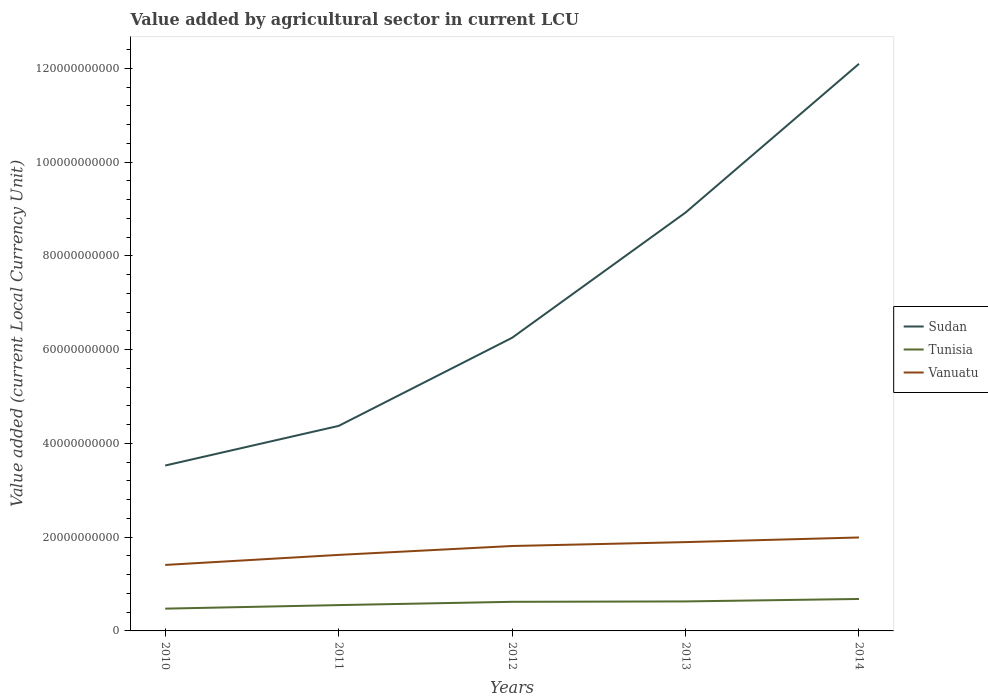How many different coloured lines are there?
Make the answer very short. 3. Is the number of lines equal to the number of legend labels?
Keep it short and to the point. Yes. Across all years, what is the maximum value added by agricultural sector in Vanuatu?
Make the answer very short. 1.41e+1. In which year was the value added by agricultural sector in Tunisia maximum?
Give a very brief answer. 2010. What is the total value added by agricultural sector in Vanuatu in the graph?
Offer a terse response. -2.73e+09. What is the difference between the highest and the second highest value added by agricultural sector in Sudan?
Keep it short and to the point. 8.57e+1. Is the value added by agricultural sector in Vanuatu strictly greater than the value added by agricultural sector in Sudan over the years?
Your answer should be compact. Yes. How many lines are there?
Your answer should be very brief. 3. What is the difference between two consecutive major ticks on the Y-axis?
Ensure brevity in your answer.  2.00e+1. Are the values on the major ticks of Y-axis written in scientific E-notation?
Make the answer very short. No. Does the graph contain grids?
Your response must be concise. No. How many legend labels are there?
Offer a terse response. 3. What is the title of the graph?
Your answer should be very brief. Value added by agricultural sector in current LCU. Does "Pacific island small states" appear as one of the legend labels in the graph?
Give a very brief answer. No. What is the label or title of the X-axis?
Your answer should be compact. Years. What is the label or title of the Y-axis?
Your answer should be very brief. Value added (current Local Currency Unit). What is the Value added (current Local Currency Unit) in Sudan in 2010?
Your answer should be compact. 3.53e+1. What is the Value added (current Local Currency Unit) of Tunisia in 2010?
Offer a terse response. 4.75e+09. What is the Value added (current Local Currency Unit) in Vanuatu in 2010?
Your response must be concise. 1.41e+1. What is the Value added (current Local Currency Unit) in Sudan in 2011?
Your response must be concise. 4.37e+1. What is the Value added (current Local Currency Unit) of Tunisia in 2011?
Provide a succinct answer. 5.51e+09. What is the Value added (current Local Currency Unit) in Vanuatu in 2011?
Give a very brief answer. 1.62e+1. What is the Value added (current Local Currency Unit) of Sudan in 2012?
Ensure brevity in your answer.  6.25e+1. What is the Value added (current Local Currency Unit) of Tunisia in 2012?
Offer a terse response. 6.21e+09. What is the Value added (current Local Currency Unit) in Vanuatu in 2012?
Your answer should be compact. 1.81e+1. What is the Value added (current Local Currency Unit) of Sudan in 2013?
Provide a short and direct response. 8.92e+1. What is the Value added (current Local Currency Unit) in Tunisia in 2013?
Your answer should be compact. 6.29e+09. What is the Value added (current Local Currency Unit) in Vanuatu in 2013?
Your answer should be compact. 1.89e+1. What is the Value added (current Local Currency Unit) of Sudan in 2014?
Your answer should be very brief. 1.21e+11. What is the Value added (current Local Currency Unit) of Tunisia in 2014?
Provide a succinct answer. 6.81e+09. What is the Value added (current Local Currency Unit) in Vanuatu in 2014?
Provide a short and direct response. 1.99e+1. Across all years, what is the maximum Value added (current Local Currency Unit) in Sudan?
Your answer should be compact. 1.21e+11. Across all years, what is the maximum Value added (current Local Currency Unit) of Tunisia?
Provide a succinct answer. 6.81e+09. Across all years, what is the maximum Value added (current Local Currency Unit) of Vanuatu?
Keep it short and to the point. 1.99e+1. Across all years, what is the minimum Value added (current Local Currency Unit) of Sudan?
Your response must be concise. 3.53e+1. Across all years, what is the minimum Value added (current Local Currency Unit) in Tunisia?
Your response must be concise. 4.75e+09. Across all years, what is the minimum Value added (current Local Currency Unit) of Vanuatu?
Your answer should be very brief. 1.41e+1. What is the total Value added (current Local Currency Unit) in Sudan in the graph?
Make the answer very short. 3.52e+11. What is the total Value added (current Local Currency Unit) in Tunisia in the graph?
Your answer should be very brief. 2.96e+1. What is the total Value added (current Local Currency Unit) in Vanuatu in the graph?
Give a very brief answer. 8.73e+1. What is the difference between the Value added (current Local Currency Unit) in Sudan in 2010 and that in 2011?
Give a very brief answer. -8.45e+09. What is the difference between the Value added (current Local Currency Unit) of Tunisia in 2010 and that in 2011?
Give a very brief answer. -7.59e+08. What is the difference between the Value added (current Local Currency Unit) of Vanuatu in 2010 and that in 2011?
Keep it short and to the point. -2.14e+09. What is the difference between the Value added (current Local Currency Unit) of Sudan in 2010 and that in 2012?
Your answer should be compact. -2.72e+1. What is the difference between the Value added (current Local Currency Unit) in Tunisia in 2010 and that in 2012?
Keep it short and to the point. -1.46e+09. What is the difference between the Value added (current Local Currency Unit) in Vanuatu in 2010 and that in 2012?
Make the answer very short. -4.04e+09. What is the difference between the Value added (current Local Currency Unit) in Sudan in 2010 and that in 2013?
Give a very brief answer. -5.40e+1. What is the difference between the Value added (current Local Currency Unit) of Tunisia in 2010 and that in 2013?
Ensure brevity in your answer.  -1.54e+09. What is the difference between the Value added (current Local Currency Unit) in Vanuatu in 2010 and that in 2013?
Provide a short and direct response. -4.87e+09. What is the difference between the Value added (current Local Currency Unit) of Sudan in 2010 and that in 2014?
Keep it short and to the point. -8.57e+1. What is the difference between the Value added (current Local Currency Unit) of Tunisia in 2010 and that in 2014?
Provide a short and direct response. -2.06e+09. What is the difference between the Value added (current Local Currency Unit) in Vanuatu in 2010 and that in 2014?
Your answer should be compact. -5.86e+09. What is the difference between the Value added (current Local Currency Unit) in Sudan in 2011 and that in 2012?
Your response must be concise. -1.88e+1. What is the difference between the Value added (current Local Currency Unit) in Tunisia in 2011 and that in 2012?
Provide a succinct answer. -7.00e+08. What is the difference between the Value added (current Local Currency Unit) of Vanuatu in 2011 and that in 2012?
Offer a terse response. -1.90e+09. What is the difference between the Value added (current Local Currency Unit) of Sudan in 2011 and that in 2013?
Offer a very short reply. -4.55e+1. What is the difference between the Value added (current Local Currency Unit) of Tunisia in 2011 and that in 2013?
Your response must be concise. -7.82e+08. What is the difference between the Value added (current Local Currency Unit) of Vanuatu in 2011 and that in 2013?
Offer a very short reply. -2.73e+09. What is the difference between the Value added (current Local Currency Unit) of Sudan in 2011 and that in 2014?
Keep it short and to the point. -7.72e+1. What is the difference between the Value added (current Local Currency Unit) in Tunisia in 2011 and that in 2014?
Ensure brevity in your answer.  -1.30e+09. What is the difference between the Value added (current Local Currency Unit) of Vanuatu in 2011 and that in 2014?
Provide a short and direct response. -3.72e+09. What is the difference between the Value added (current Local Currency Unit) of Sudan in 2012 and that in 2013?
Offer a very short reply. -2.67e+1. What is the difference between the Value added (current Local Currency Unit) of Tunisia in 2012 and that in 2013?
Your answer should be compact. -8.27e+07. What is the difference between the Value added (current Local Currency Unit) in Vanuatu in 2012 and that in 2013?
Ensure brevity in your answer.  -8.30e+08. What is the difference between the Value added (current Local Currency Unit) in Sudan in 2012 and that in 2014?
Your answer should be very brief. -5.84e+1. What is the difference between the Value added (current Local Currency Unit) of Tunisia in 2012 and that in 2014?
Offer a very short reply. -6.05e+08. What is the difference between the Value added (current Local Currency Unit) of Vanuatu in 2012 and that in 2014?
Your answer should be very brief. -1.82e+09. What is the difference between the Value added (current Local Currency Unit) of Sudan in 2013 and that in 2014?
Ensure brevity in your answer.  -3.17e+1. What is the difference between the Value added (current Local Currency Unit) of Tunisia in 2013 and that in 2014?
Give a very brief answer. -5.22e+08. What is the difference between the Value added (current Local Currency Unit) of Vanuatu in 2013 and that in 2014?
Keep it short and to the point. -9.87e+08. What is the difference between the Value added (current Local Currency Unit) of Sudan in 2010 and the Value added (current Local Currency Unit) of Tunisia in 2011?
Provide a short and direct response. 2.98e+1. What is the difference between the Value added (current Local Currency Unit) of Sudan in 2010 and the Value added (current Local Currency Unit) of Vanuatu in 2011?
Your response must be concise. 1.91e+1. What is the difference between the Value added (current Local Currency Unit) of Tunisia in 2010 and the Value added (current Local Currency Unit) of Vanuatu in 2011?
Keep it short and to the point. -1.15e+1. What is the difference between the Value added (current Local Currency Unit) in Sudan in 2010 and the Value added (current Local Currency Unit) in Tunisia in 2012?
Provide a short and direct response. 2.91e+1. What is the difference between the Value added (current Local Currency Unit) of Sudan in 2010 and the Value added (current Local Currency Unit) of Vanuatu in 2012?
Ensure brevity in your answer.  1.72e+1. What is the difference between the Value added (current Local Currency Unit) of Tunisia in 2010 and the Value added (current Local Currency Unit) of Vanuatu in 2012?
Give a very brief answer. -1.34e+1. What is the difference between the Value added (current Local Currency Unit) of Sudan in 2010 and the Value added (current Local Currency Unit) of Tunisia in 2013?
Your response must be concise. 2.90e+1. What is the difference between the Value added (current Local Currency Unit) in Sudan in 2010 and the Value added (current Local Currency Unit) in Vanuatu in 2013?
Your response must be concise. 1.63e+1. What is the difference between the Value added (current Local Currency Unit) of Tunisia in 2010 and the Value added (current Local Currency Unit) of Vanuatu in 2013?
Provide a succinct answer. -1.42e+1. What is the difference between the Value added (current Local Currency Unit) in Sudan in 2010 and the Value added (current Local Currency Unit) in Tunisia in 2014?
Give a very brief answer. 2.85e+1. What is the difference between the Value added (current Local Currency Unit) in Sudan in 2010 and the Value added (current Local Currency Unit) in Vanuatu in 2014?
Your answer should be compact. 1.53e+1. What is the difference between the Value added (current Local Currency Unit) of Tunisia in 2010 and the Value added (current Local Currency Unit) of Vanuatu in 2014?
Your answer should be very brief. -1.52e+1. What is the difference between the Value added (current Local Currency Unit) in Sudan in 2011 and the Value added (current Local Currency Unit) in Tunisia in 2012?
Provide a succinct answer. 3.75e+1. What is the difference between the Value added (current Local Currency Unit) of Sudan in 2011 and the Value added (current Local Currency Unit) of Vanuatu in 2012?
Your response must be concise. 2.56e+1. What is the difference between the Value added (current Local Currency Unit) of Tunisia in 2011 and the Value added (current Local Currency Unit) of Vanuatu in 2012?
Your response must be concise. -1.26e+1. What is the difference between the Value added (current Local Currency Unit) of Sudan in 2011 and the Value added (current Local Currency Unit) of Tunisia in 2013?
Give a very brief answer. 3.74e+1. What is the difference between the Value added (current Local Currency Unit) of Sudan in 2011 and the Value added (current Local Currency Unit) of Vanuatu in 2013?
Keep it short and to the point. 2.48e+1. What is the difference between the Value added (current Local Currency Unit) in Tunisia in 2011 and the Value added (current Local Currency Unit) in Vanuatu in 2013?
Your response must be concise. -1.34e+1. What is the difference between the Value added (current Local Currency Unit) of Sudan in 2011 and the Value added (current Local Currency Unit) of Tunisia in 2014?
Offer a terse response. 3.69e+1. What is the difference between the Value added (current Local Currency Unit) in Sudan in 2011 and the Value added (current Local Currency Unit) in Vanuatu in 2014?
Provide a short and direct response. 2.38e+1. What is the difference between the Value added (current Local Currency Unit) in Tunisia in 2011 and the Value added (current Local Currency Unit) in Vanuatu in 2014?
Your answer should be very brief. -1.44e+1. What is the difference between the Value added (current Local Currency Unit) of Sudan in 2012 and the Value added (current Local Currency Unit) of Tunisia in 2013?
Your answer should be very brief. 5.62e+1. What is the difference between the Value added (current Local Currency Unit) of Sudan in 2012 and the Value added (current Local Currency Unit) of Vanuatu in 2013?
Keep it short and to the point. 4.36e+1. What is the difference between the Value added (current Local Currency Unit) in Tunisia in 2012 and the Value added (current Local Currency Unit) in Vanuatu in 2013?
Your response must be concise. -1.27e+1. What is the difference between the Value added (current Local Currency Unit) of Sudan in 2012 and the Value added (current Local Currency Unit) of Tunisia in 2014?
Your answer should be very brief. 5.57e+1. What is the difference between the Value added (current Local Currency Unit) of Sudan in 2012 and the Value added (current Local Currency Unit) of Vanuatu in 2014?
Keep it short and to the point. 4.26e+1. What is the difference between the Value added (current Local Currency Unit) in Tunisia in 2012 and the Value added (current Local Currency Unit) in Vanuatu in 2014?
Offer a very short reply. -1.37e+1. What is the difference between the Value added (current Local Currency Unit) in Sudan in 2013 and the Value added (current Local Currency Unit) in Tunisia in 2014?
Keep it short and to the point. 8.24e+1. What is the difference between the Value added (current Local Currency Unit) in Sudan in 2013 and the Value added (current Local Currency Unit) in Vanuatu in 2014?
Keep it short and to the point. 6.93e+1. What is the difference between the Value added (current Local Currency Unit) in Tunisia in 2013 and the Value added (current Local Currency Unit) in Vanuatu in 2014?
Your response must be concise. -1.36e+1. What is the average Value added (current Local Currency Unit) of Sudan per year?
Give a very brief answer. 7.04e+1. What is the average Value added (current Local Currency Unit) of Tunisia per year?
Provide a short and direct response. 5.92e+09. What is the average Value added (current Local Currency Unit) in Vanuatu per year?
Ensure brevity in your answer.  1.75e+1. In the year 2010, what is the difference between the Value added (current Local Currency Unit) of Sudan and Value added (current Local Currency Unit) of Tunisia?
Ensure brevity in your answer.  3.05e+1. In the year 2010, what is the difference between the Value added (current Local Currency Unit) of Sudan and Value added (current Local Currency Unit) of Vanuatu?
Offer a very short reply. 2.12e+1. In the year 2010, what is the difference between the Value added (current Local Currency Unit) of Tunisia and Value added (current Local Currency Unit) of Vanuatu?
Provide a succinct answer. -9.32e+09. In the year 2011, what is the difference between the Value added (current Local Currency Unit) in Sudan and Value added (current Local Currency Unit) in Tunisia?
Make the answer very short. 3.82e+1. In the year 2011, what is the difference between the Value added (current Local Currency Unit) of Sudan and Value added (current Local Currency Unit) of Vanuatu?
Your answer should be very brief. 2.75e+1. In the year 2011, what is the difference between the Value added (current Local Currency Unit) of Tunisia and Value added (current Local Currency Unit) of Vanuatu?
Make the answer very short. -1.07e+1. In the year 2012, what is the difference between the Value added (current Local Currency Unit) of Sudan and Value added (current Local Currency Unit) of Tunisia?
Your answer should be very brief. 5.63e+1. In the year 2012, what is the difference between the Value added (current Local Currency Unit) of Sudan and Value added (current Local Currency Unit) of Vanuatu?
Give a very brief answer. 4.44e+1. In the year 2012, what is the difference between the Value added (current Local Currency Unit) in Tunisia and Value added (current Local Currency Unit) in Vanuatu?
Offer a very short reply. -1.19e+1. In the year 2013, what is the difference between the Value added (current Local Currency Unit) in Sudan and Value added (current Local Currency Unit) in Tunisia?
Ensure brevity in your answer.  8.29e+1. In the year 2013, what is the difference between the Value added (current Local Currency Unit) in Sudan and Value added (current Local Currency Unit) in Vanuatu?
Provide a succinct answer. 7.03e+1. In the year 2013, what is the difference between the Value added (current Local Currency Unit) of Tunisia and Value added (current Local Currency Unit) of Vanuatu?
Provide a succinct answer. -1.27e+1. In the year 2014, what is the difference between the Value added (current Local Currency Unit) of Sudan and Value added (current Local Currency Unit) of Tunisia?
Your answer should be compact. 1.14e+11. In the year 2014, what is the difference between the Value added (current Local Currency Unit) of Sudan and Value added (current Local Currency Unit) of Vanuatu?
Offer a very short reply. 1.01e+11. In the year 2014, what is the difference between the Value added (current Local Currency Unit) of Tunisia and Value added (current Local Currency Unit) of Vanuatu?
Your answer should be compact. -1.31e+1. What is the ratio of the Value added (current Local Currency Unit) of Sudan in 2010 to that in 2011?
Give a very brief answer. 0.81. What is the ratio of the Value added (current Local Currency Unit) of Tunisia in 2010 to that in 2011?
Offer a very short reply. 0.86. What is the ratio of the Value added (current Local Currency Unit) of Vanuatu in 2010 to that in 2011?
Your answer should be very brief. 0.87. What is the ratio of the Value added (current Local Currency Unit) in Sudan in 2010 to that in 2012?
Offer a terse response. 0.56. What is the ratio of the Value added (current Local Currency Unit) in Tunisia in 2010 to that in 2012?
Give a very brief answer. 0.77. What is the ratio of the Value added (current Local Currency Unit) in Vanuatu in 2010 to that in 2012?
Offer a terse response. 0.78. What is the ratio of the Value added (current Local Currency Unit) in Sudan in 2010 to that in 2013?
Your answer should be very brief. 0.4. What is the ratio of the Value added (current Local Currency Unit) of Tunisia in 2010 to that in 2013?
Offer a terse response. 0.76. What is the ratio of the Value added (current Local Currency Unit) of Vanuatu in 2010 to that in 2013?
Provide a succinct answer. 0.74. What is the ratio of the Value added (current Local Currency Unit) in Sudan in 2010 to that in 2014?
Provide a succinct answer. 0.29. What is the ratio of the Value added (current Local Currency Unit) of Tunisia in 2010 to that in 2014?
Give a very brief answer. 0.7. What is the ratio of the Value added (current Local Currency Unit) of Vanuatu in 2010 to that in 2014?
Offer a terse response. 0.71. What is the ratio of the Value added (current Local Currency Unit) of Sudan in 2011 to that in 2012?
Your answer should be compact. 0.7. What is the ratio of the Value added (current Local Currency Unit) in Tunisia in 2011 to that in 2012?
Make the answer very short. 0.89. What is the ratio of the Value added (current Local Currency Unit) in Vanuatu in 2011 to that in 2012?
Make the answer very short. 0.9. What is the ratio of the Value added (current Local Currency Unit) of Sudan in 2011 to that in 2013?
Give a very brief answer. 0.49. What is the ratio of the Value added (current Local Currency Unit) in Tunisia in 2011 to that in 2013?
Offer a terse response. 0.88. What is the ratio of the Value added (current Local Currency Unit) in Vanuatu in 2011 to that in 2013?
Your response must be concise. 0.86. What is the ratio of the Value added (current Local Currency Unit) of Sudan in 2011 to that in 2014?
Offer a terse response. 0.36. What is the ratio of the Value added (current Local Currency Unit) of Tunisia in 2011 to that in 2014?
Provide a succinct answer. 0.81. What is the ratio of the Value added (current Local Currency Unit) in Vanuatu in 2011 to that in 2014?
Give a very brief answer. 0.81. What is the ratio of the Value added (current Local Currency Unit) in Sudan in 2012 to that in 2013?
Your response must be concise. 0.7. What is the ratio of the Value added (current Local Currency Unit) in Tunisia in 2012 to that in 2013?
Your answer should be compact. 0.99. What is the ratio of the Value added (current Local Currency Unit) in Vanuatu in 2012 to that in 2013?
Your answer should be very brief. 0.96. What is the ratio of the Value added (current Local Currency Unit) in Sudan in 2012 to that in 2014?
Give a very brief answer. 0.52. What is the ratio of the Value added (current Local Currency Unit) in Tunisia in 2012 to that in 2014?
Your answer should be very brief. 0.91. What is the ratio of the Value added (current Local Currency Unit) in Vanuatu in 2012 to that in 2014?
Give a very brief answer. 0.91. What is the ratio of the Value added (current Local Currency Unit) of Sudan in 2013 to that in 2014?
Your response must be concise. 0.74. What is the ratio of the Value added (current Local Currency Unit) in Tunisia in 2013 to that in 2014?
Offer a very short reply. 0.92. What is the ratio of the Value added (current Local Currency Unit) in Vanuatu in 2013 to that in 2014?
Offer a terse response. 0.95. What is the difference between the highest and the second highest Value added (current Local Currency Unit) in Sudan?
Ensure brevity in your answer.  3.17e+1. What is the difference between the highest and the second highest Value added (current Local Currency Unit) of Tunisia?
Your answer should be compact. 5.22e+08. What is the difference between the highest and the second highest Value added (current Local Currency Unit) of Vanuatu?
Your response must be concise. 9.87e+08. What is the difference between the highest and the lowest Value added (current Local Currency Unit) in Sudan?
Ensure brevity in your answer.  8.57e+1. What is the difference between the highest and the lowest Value added (current Local Currency Unit) of Tunisia?
Provide a short and direct response. 2.06e+09. What is the difference between the highest and the lowest Value added (current Local Currency Unit) in Vanuatu?
Offer a very short reply. 5.86e+09. 